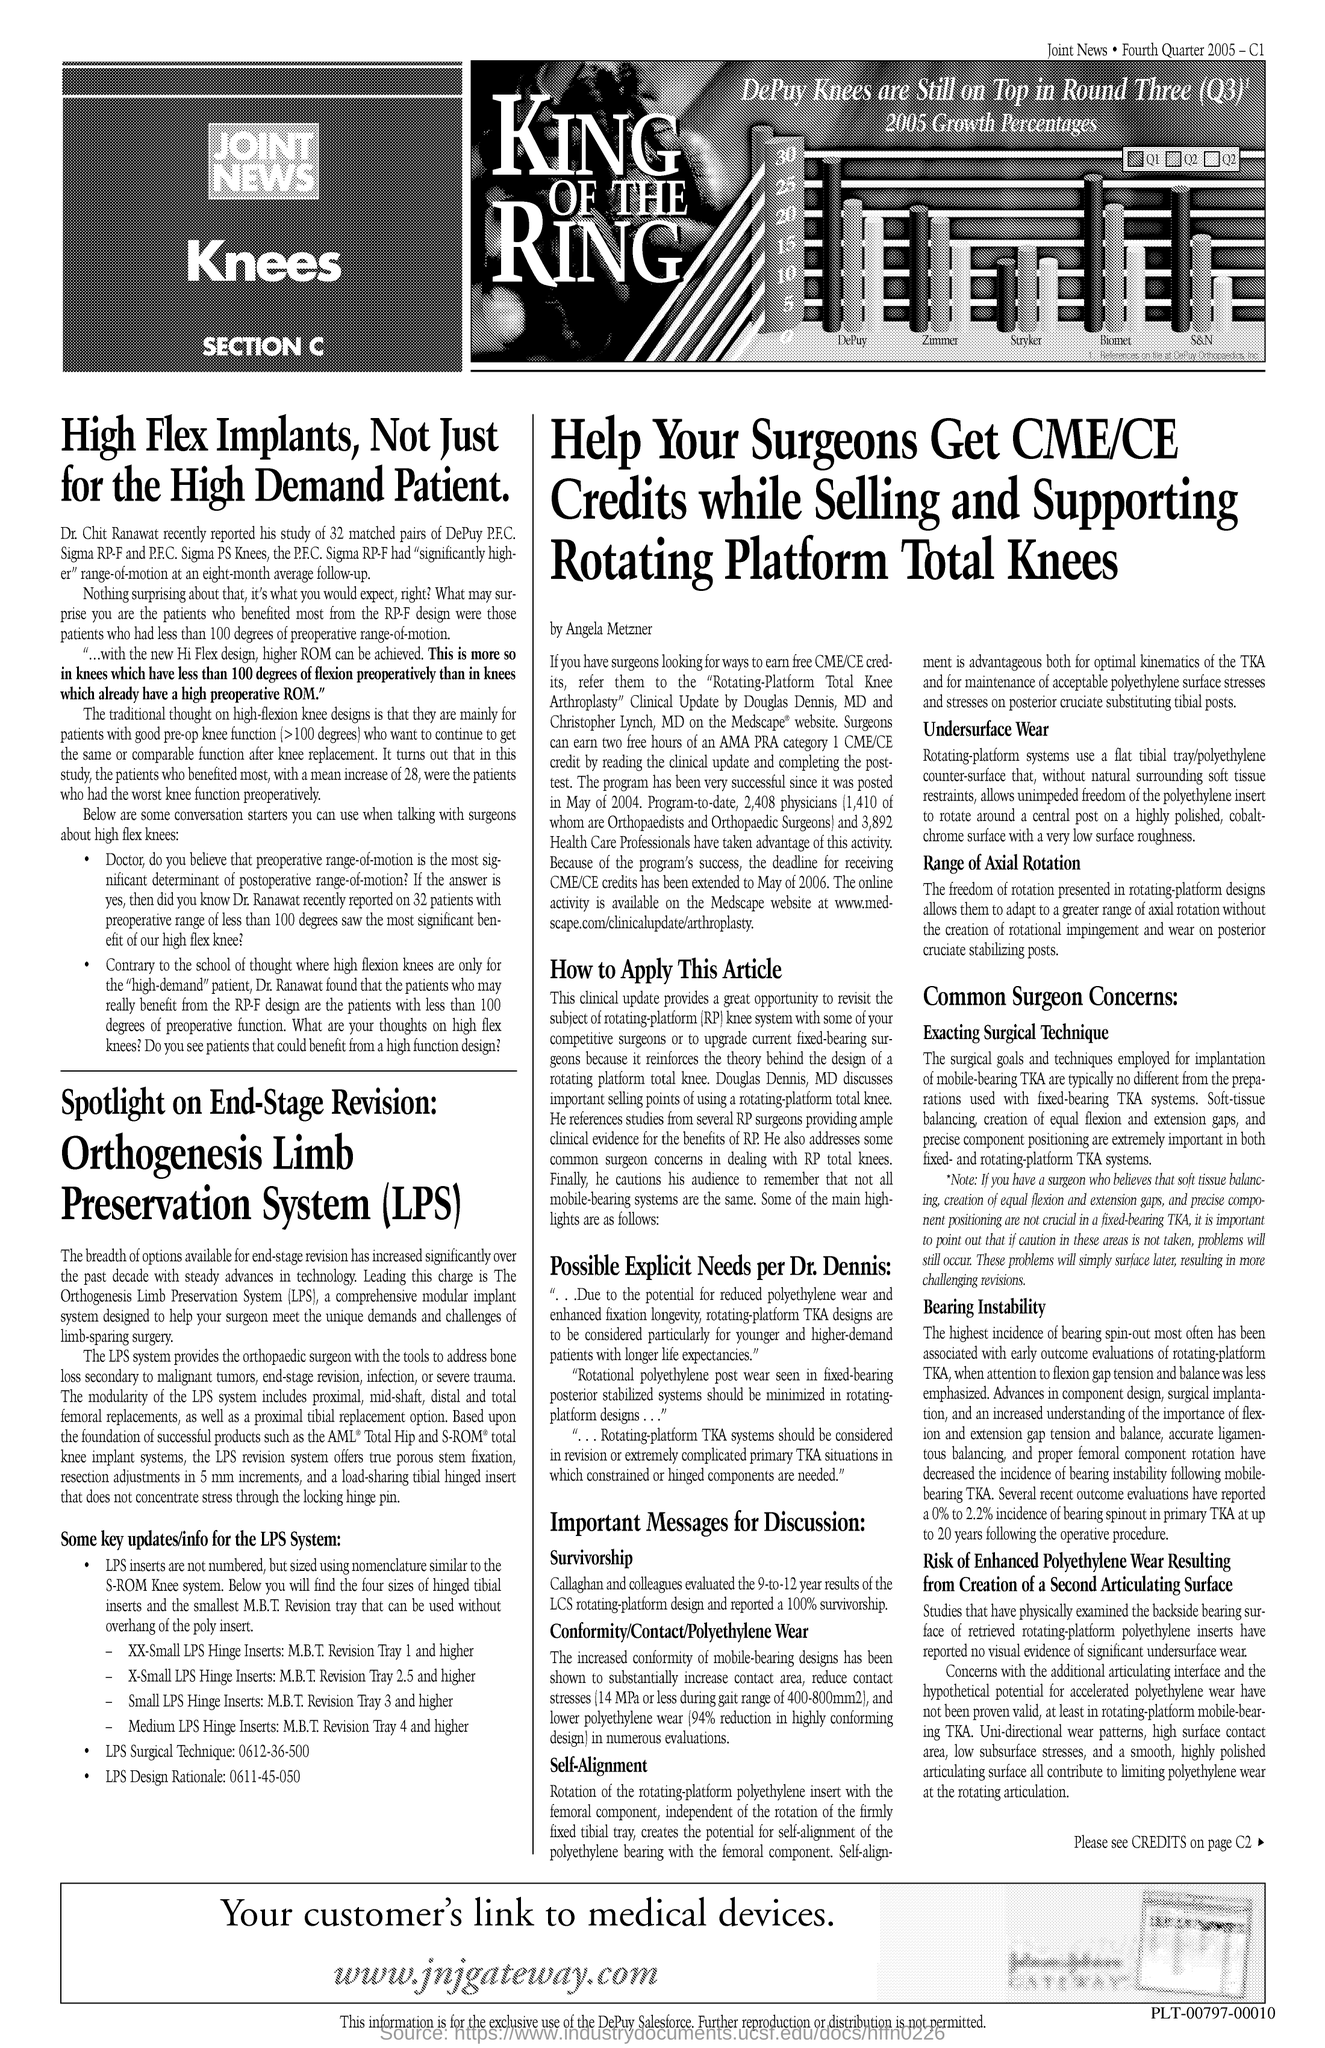What is the url mentioned in the document?
Your response must be concise. Www.jnjgateway.com. 